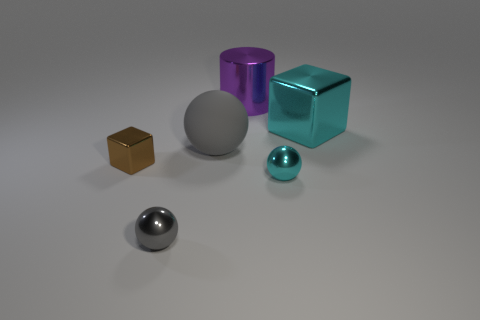Add 3 big gray matte things. How many objects exist? 9 Subtract all blocks. How many objects are left? 4 Add 2 big spheres. How many big spheres exist? 3 Subtract 0 purple blocks. How many objects are left? 6 Subtract all big gray matte spheres. Subtract all big gray shiny spheres. How many objects are left? 5 Add 5 brown blocks. How many brown blocks are left? 6 